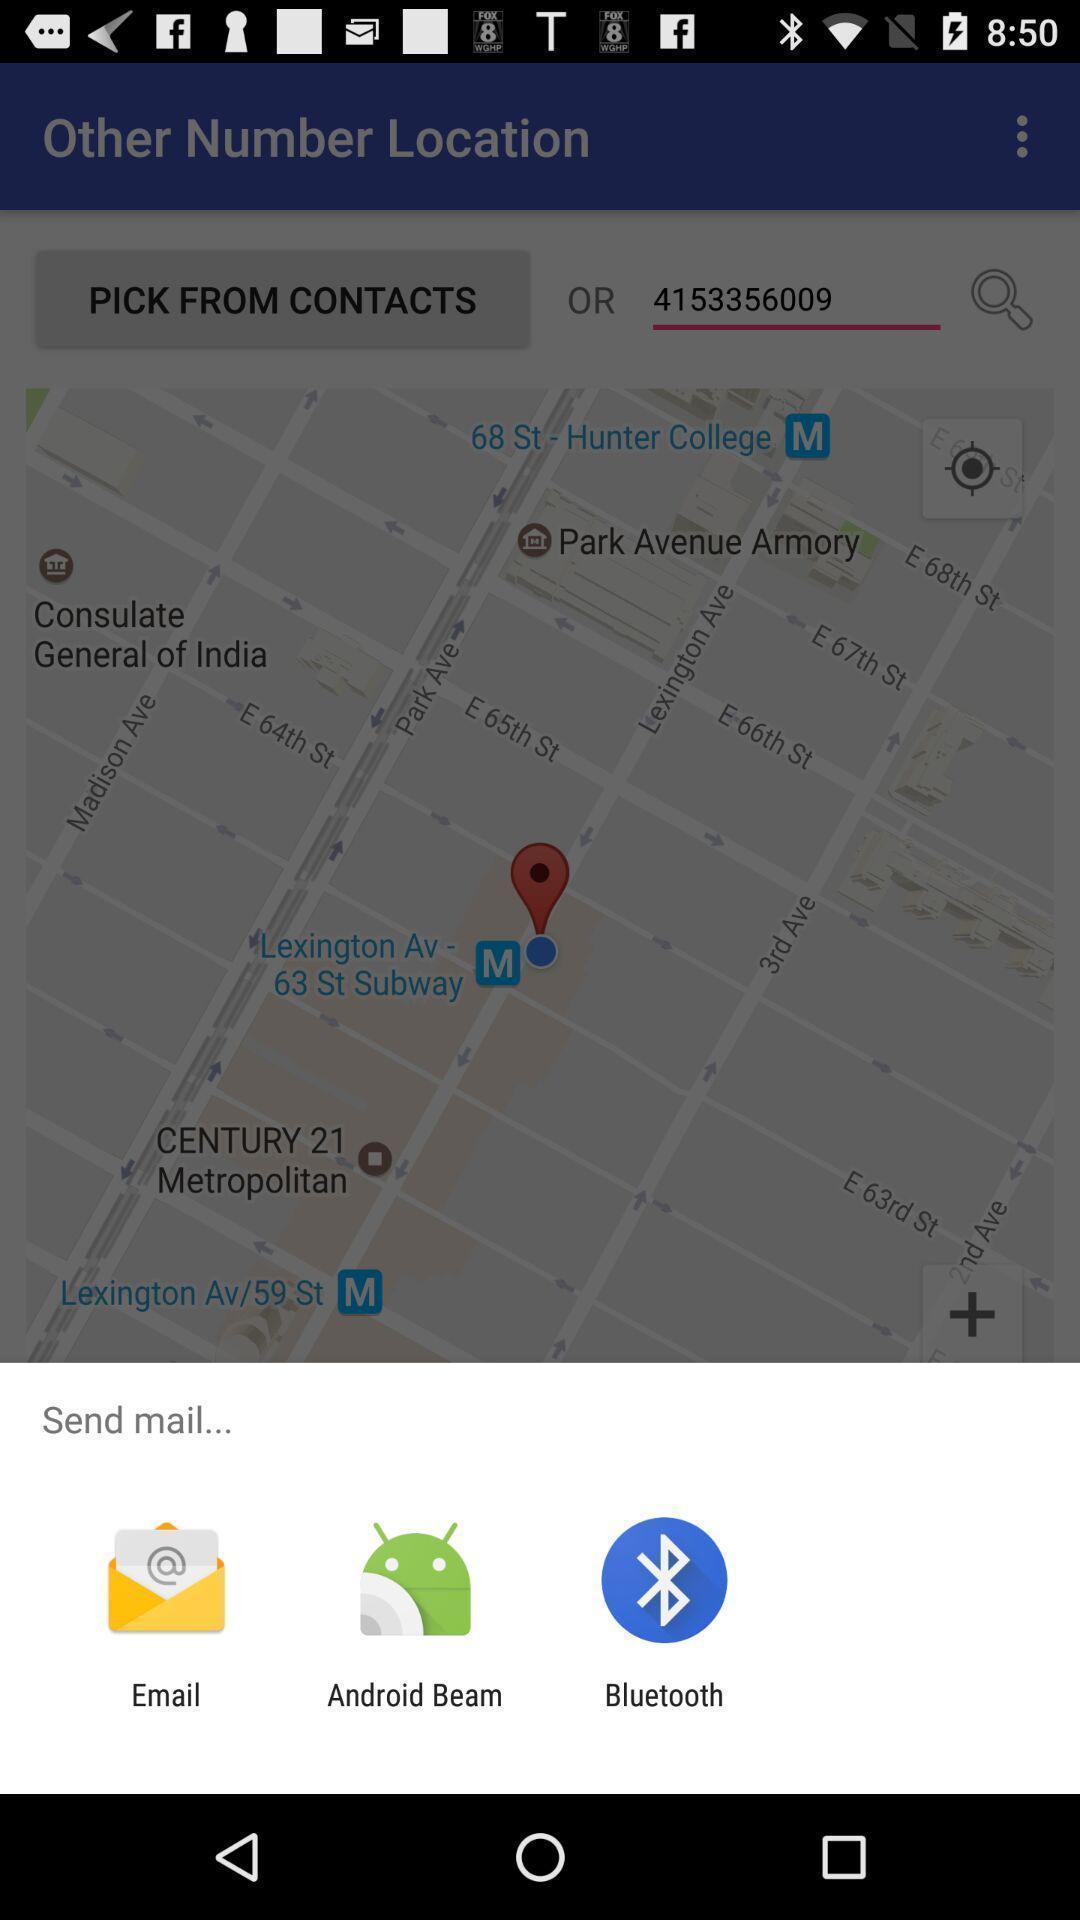Summarize the main components in this picture. Pop-up shows send mail to with multiple apps options. 